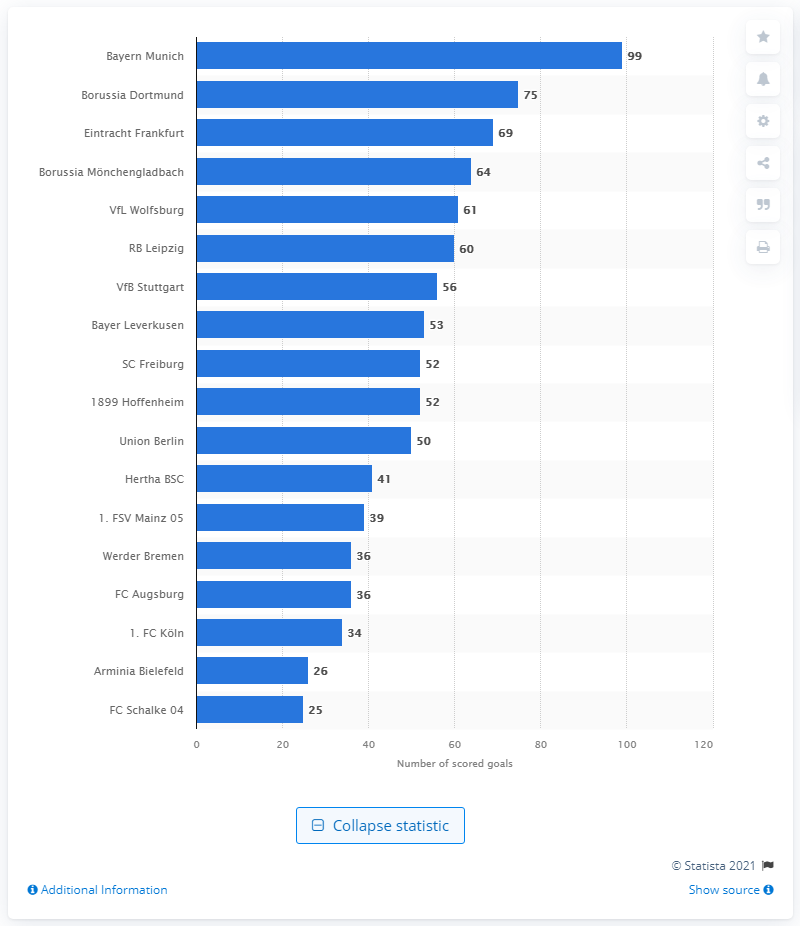List a handful of essential elements in this visual. As of the current season, FC Bayern Munich has scored a total of 99 goals. Borussia Dortmund has scored a total of 75 goals in the current season. 